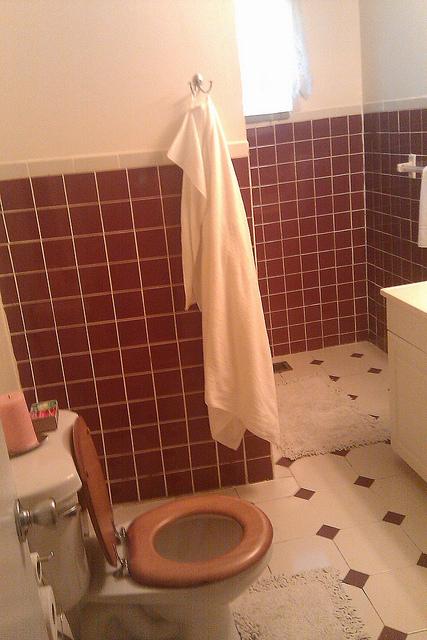How many toilets are in the bathroom?
Quick response, please. 1. Why is there a seat on the toilet bowl?
Be succinct. To sit on. How many tiles are in the bathroom?
Write a very short answer. Many. 